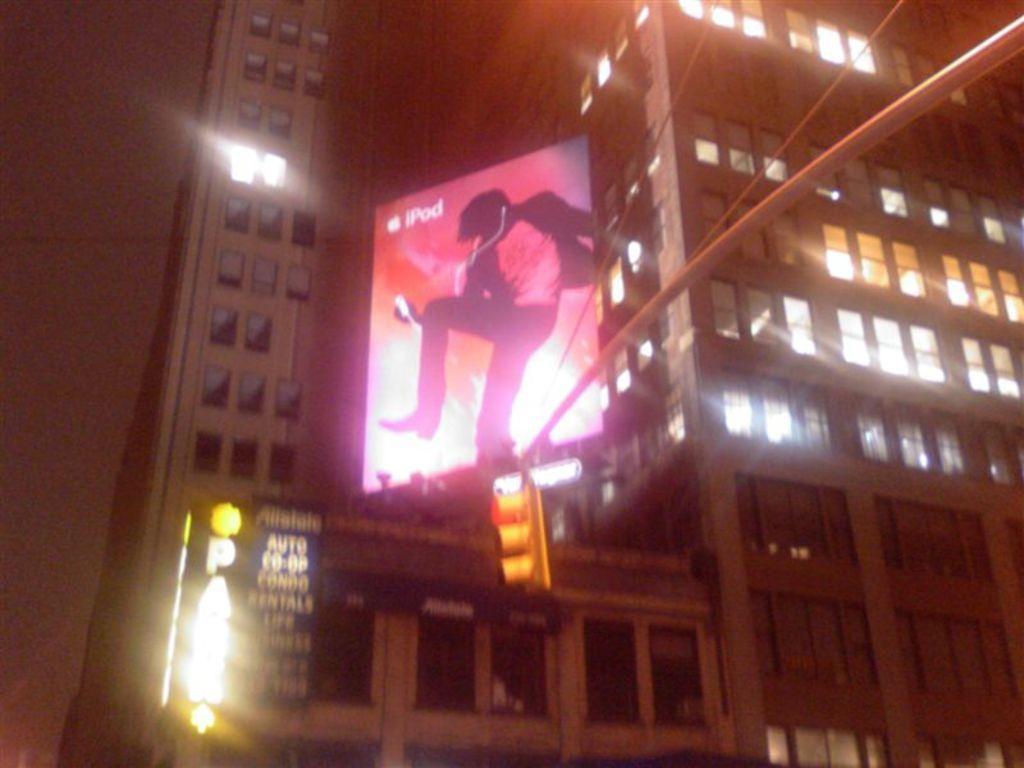Can you describe this image briefly? In the image we can see there are buildings and there is a banner on top of the building. There is a traffic light signal. 